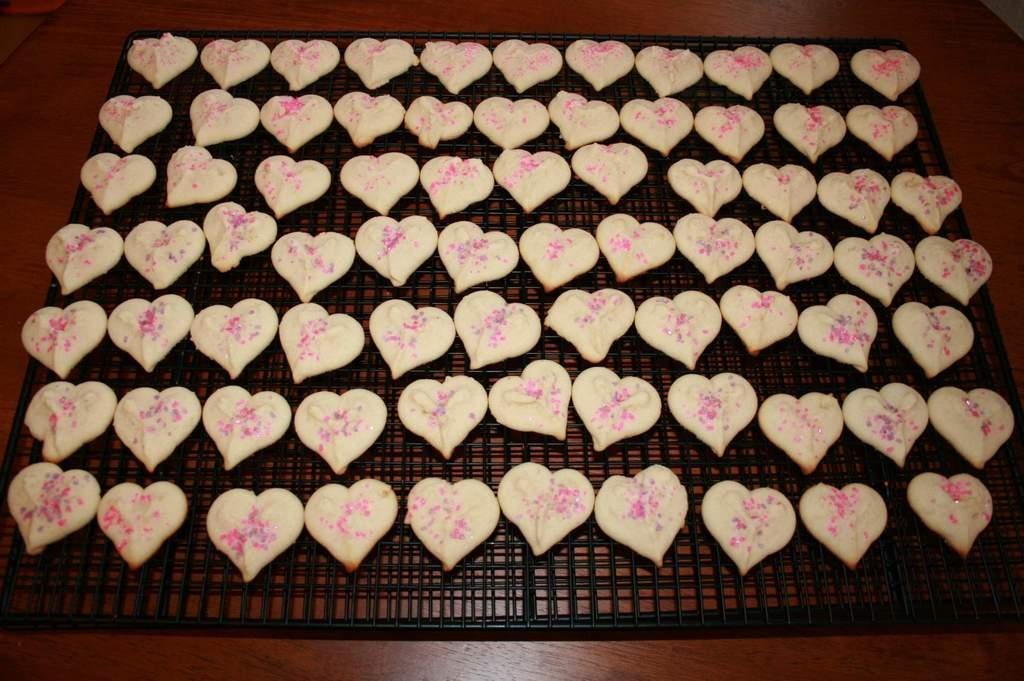What is being cooked on the grill in the image? There are cookies on a grill in the image. Where is the grill located in the image? The grill is on the floor. Can you describe the setting where the image might have been taken? The image might have been taken in a hall. What type of cord is used to control the journey of the cookies in the image? There is no mention of a cord or journey in the image, as it features cookies on a grill and the grill's location. 